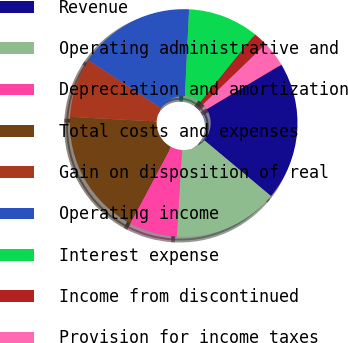Convert chart. <chart><loc_0><loc_0><loc_500><loc_500><pie_chart><fcel>Revenue<fcel>Operating administrative and<fcel>Depreciation and amortization<fcel>Total costs and expenses<fcel>Gain on disposition of real<fcel>Operating income<fcel>Interest expense<fcel>Income from discontinued<fcel>Provision for income taxes<nl><fcel>19.67%<fcel>14.86%<fcel>6.83%<fcel>18.07%<fcel>8.44%<fcel>16.46%<fcel>10.04%<fcel>2.01%<fcel>3.62%<nl></chart> 